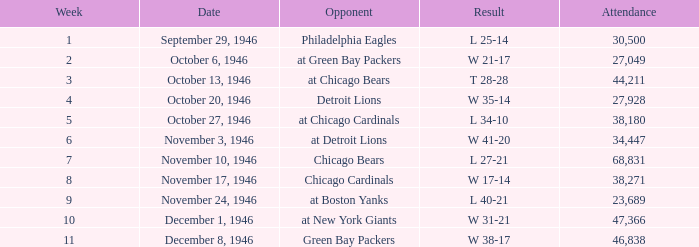For games where the outcome was a 35-14 win, what was the accumulated attendance? 27928.0. 